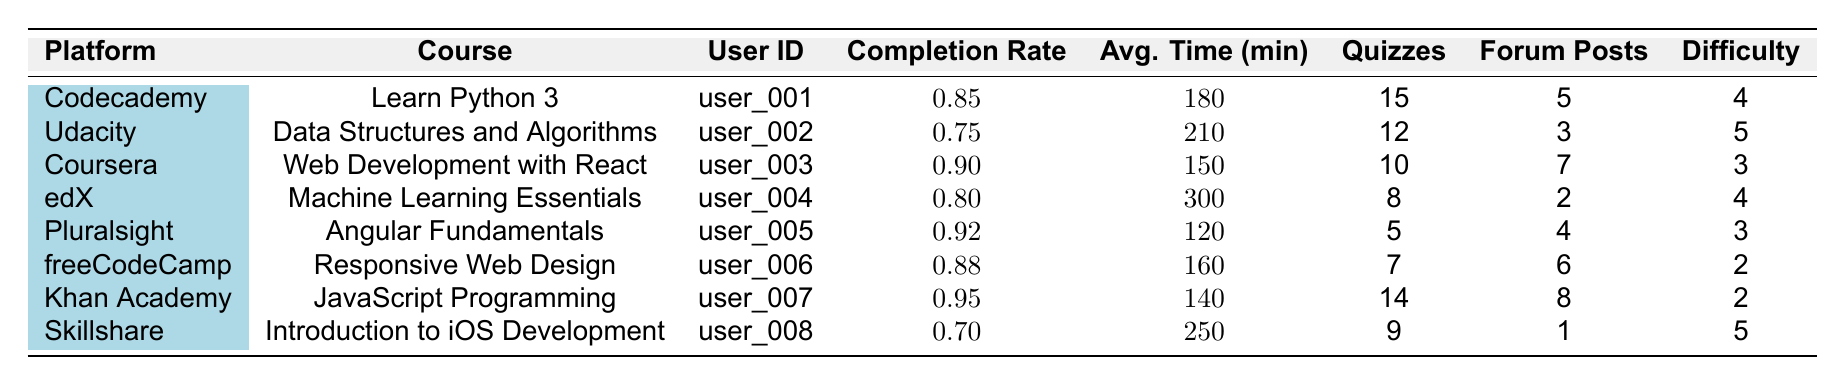What is the completion rate of the course "Learn Python 3"? Looking at the row for the course "Learn Python 3" under Codecademy, the completion rate is listed as 0.85.
Answer: 0.85 Which platform has the course with the highest completion rate? The course with the highest completion rate is "JavaScript Programming" from Khan Academy, which has a completion rate of 0.95.
Answer: Khan Academy What is the average time spent on the course "Web Development with React"? For the course "Web Development with React" on the Coursera platform, the average time spent is 150 minutes.
Answer: 150 Is the completion rate for "Introduction to iOS Development" greater than 0.8? The completion rate for "Introduction to iOS Development" from Skillshare is 0.70, which is not greater than 0.8.
Answer: No How many quizzes were completed in total across all courses? By summing the quizzes completed in each course: 15 + 12 + 10 + 8 + 5 + 7 + 14 + 9 = 80 quizzes in total.
Answer: 80 What is the average difficulty rating for all the courses listed? Summing the difficulty ratings: 4 + 5 + 3 + 4 + 3 + 2 + 2 + 5 = 28. There are 8 courses, so the average difficulty rating is 28 / 8 = 3.5.
Answer: 3.5 Who spent the most time on their course? Looking through the average time spent, "Machine Learning Essentials" on edX has the highest average time at 300 minutes.
Answer: edX Does any course have a completion rate below 0.75? The course "Data Structures and Algorithms" from Udacity has a completion rate of 0.75, while "Introduction to iOS Development" has a completion rate of 0.70, which is below 0.75.
Answer: Yes Which user completed more quizzes, user_001 or user_005? User_001 completed 15 quizzes for "Learn Python 3" and user_005 completed 5 quizzes for "Angular Fundamentals". Comparing these, user_001 completed more quizzes.
Answer: user_001 Calculate the difference in average time spent between the courses with the highest and lowest completion rates. The course with the highest completion rate, "JavaScript Programming" (user_007), has an average time spent of 140 minutes. The course with the lowest, "Data Structures and Algorithms" (user_002), has 210 minutes. The difference is 210 - 140 = 70 minutes.
Answer: 70 